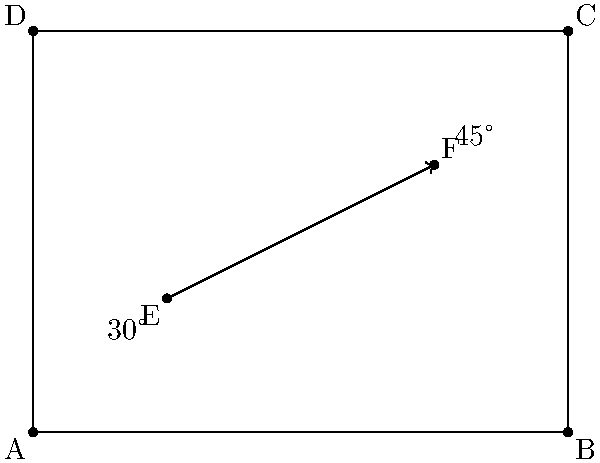In your space station novel, a laser beam is fired from point E $(2,2)$ towards point F $(6,4)$ in a rectangular room ABCD. The beam reflects off the ceiling at point F and then off the right wall. If the angle of incidence at point F is $30°$ and the angle of reflection off the right wall is $45°$, determine the coordinates of the final point where the laser beam hits the floor. Let's approach this step-by-step:

1) First, we need to find the equation of the line EF:
   Slope of EF = $\frac{4-2}{6-2} = \frac{1}{2}$
   Equation of EF: $y = \frac{1}{2}x + 1$

2) At point F, the angle of incidence is $30°$. The angle of reflection will also be $30°$, making a total of $60°$ from the ceiling.

3) The equation of the ceiling is $y = 6$. The reflected beam from F will have a slope of $\tan(60°) = \sqrt{3}$.

4) Equation of the reflected beam from F:
   $y - 4 = -\sqrt{3}(x - 6)$ (negative because it's going down)

5) To find where this beam hits the right wall $(x = 8)$, we substitute $x = 8$:
   $y - 4 = -\sqrt{3}(8 - 6)$
   $y = 4 - 2\sqrt{3}$

6) From this point on the right wall, the beam reflects at a $45°$ angle. The slope of this final segment will be $\tan(45°) = 1$.

7) Equation of the final beam segment:
   $y - (4 - 2\sqrt{3}) = -(x - 8)$ (negative because it's going down and left)

8) To find where this hits the floor $(y = 0)$, we set $y = 0$:
   $0 - (4 - 2\sqrt{3}) = -(x - 8)$
   $x = 12 - 2\sqrt{3}$

Therefore, the final coordinates are $(12 - 2\sqrt{3}, 0)$.
Answer: $(12 - 2\sqrt{3}, 0)$ 